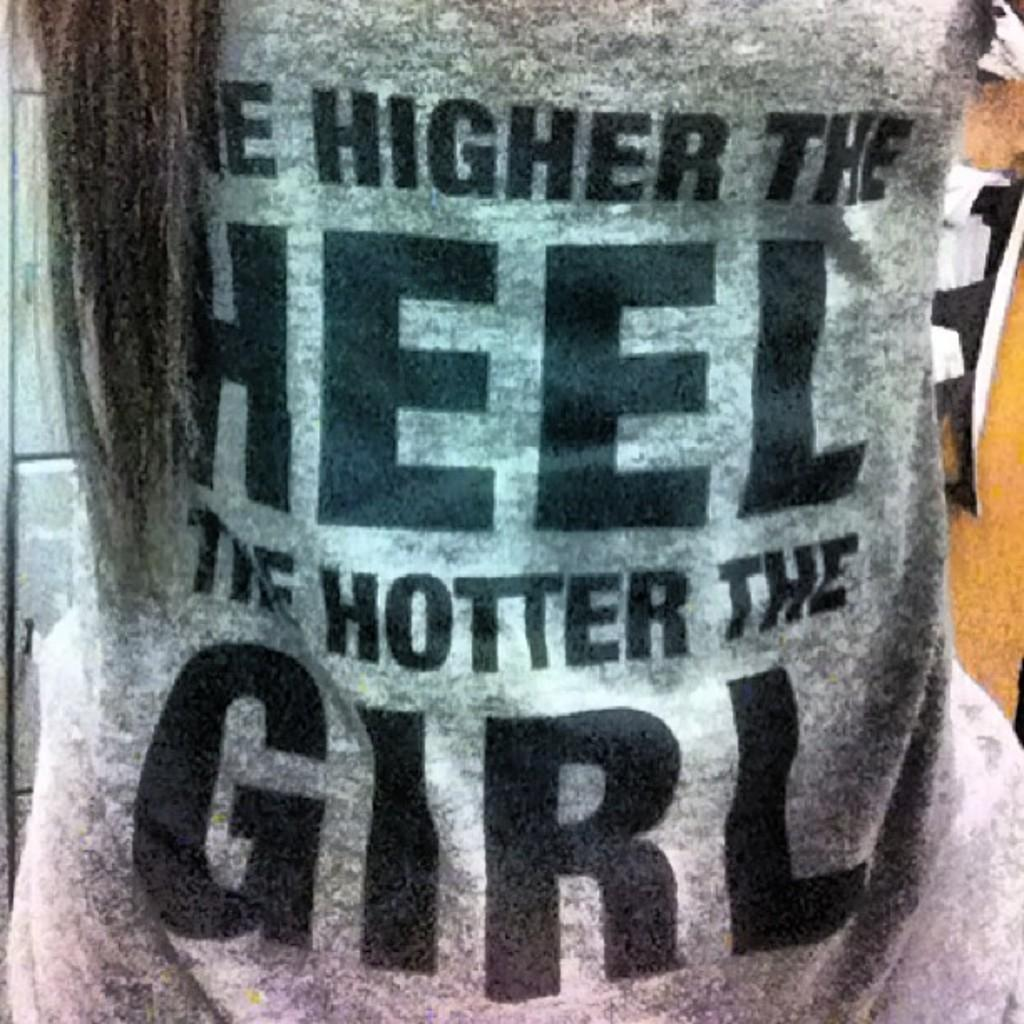What type of clothing item is present in the image? There is a t-shirt in the image. What is featured on the t-shirt? The t-shirt has text on it. What type of writer is depicted on the t-shirt in the image? There is no writer depicted on the t-shirt in the image; it only has text on it. 